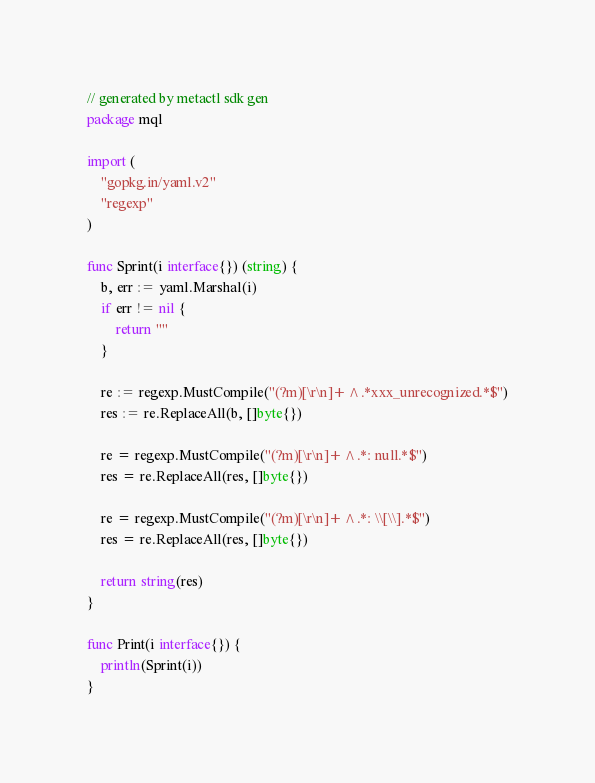<code> <loc_0><loc_0><loc_500><loc_500><_Go_>// generated by metactl sdk gen 
package mql

import (
	"gopkg.in/yaml.v2"
	"regexp"
)

func Sprint(i interface{}) (string) {
	b, err := yaml.Marshal(i)
	if err != nil {
		return ""
	}

	re := regexp.MustCompile("(?m)[\r\n]+^.*xxx_unrecognized.*$")
	res := re.ReplaceAll(b, []byte{})

	re = regexp.MustCompile("(?m)[\r\n]+^.*: null.*$")
	res = re.ReplaceAll(res, []byte{})

	re = regexp.MustCompile("(?m)[\r\n]+^.*: \\[\\].*$")
	res = re.ReplaceAll(res, []byte{})

	return string(res)
}

func Print(i interface{}) {
	println(Sprint(i))
}</code> 